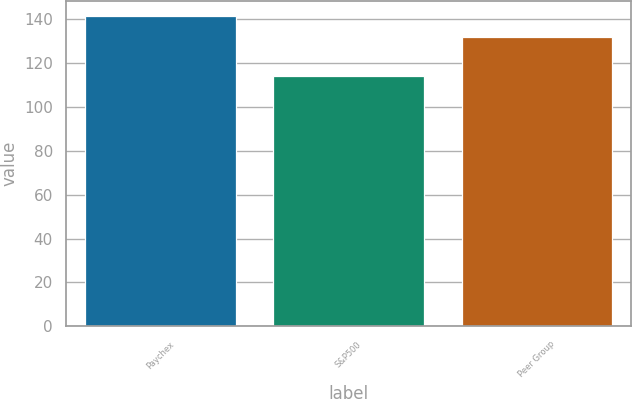Convert chart to OTSL. <chart><loc_0><loc_0><loc_500><loc_500><bar_chart><fcel>Paychex<fcel>S&P500<fcel>Peer Group<nl><fcel>141.11<fcel>113.72<fcel>131.81<nl></chart> 